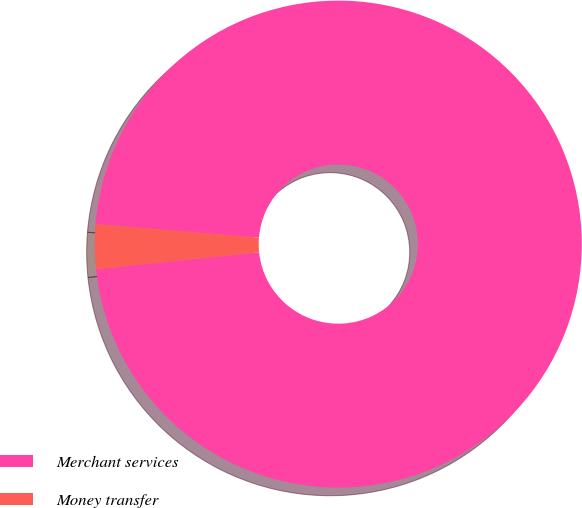Convert chart. <chart><loc_0><loc_0><loc_500><loc_500><pie_chart><fcel>Merchant services<fcel>Money transfer<nl><fcel>97.04%<fcel>2.96%<nl></chart> 